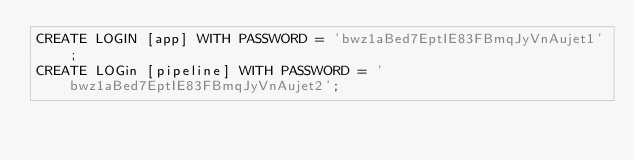Convert code to text. <code><loc_0><loc_0><loc_500><loc_500><_SQL_>CREATE LOGIN [app] WITH PASSWORD = 'bwz1aBed7EptIE83FBmqJyVnAujet1';
CREATE LOGin [pipeline] WITH PASSWORD = 'bwz1aBed7EptIE83FBmqJyVnAujet2';
</code> 